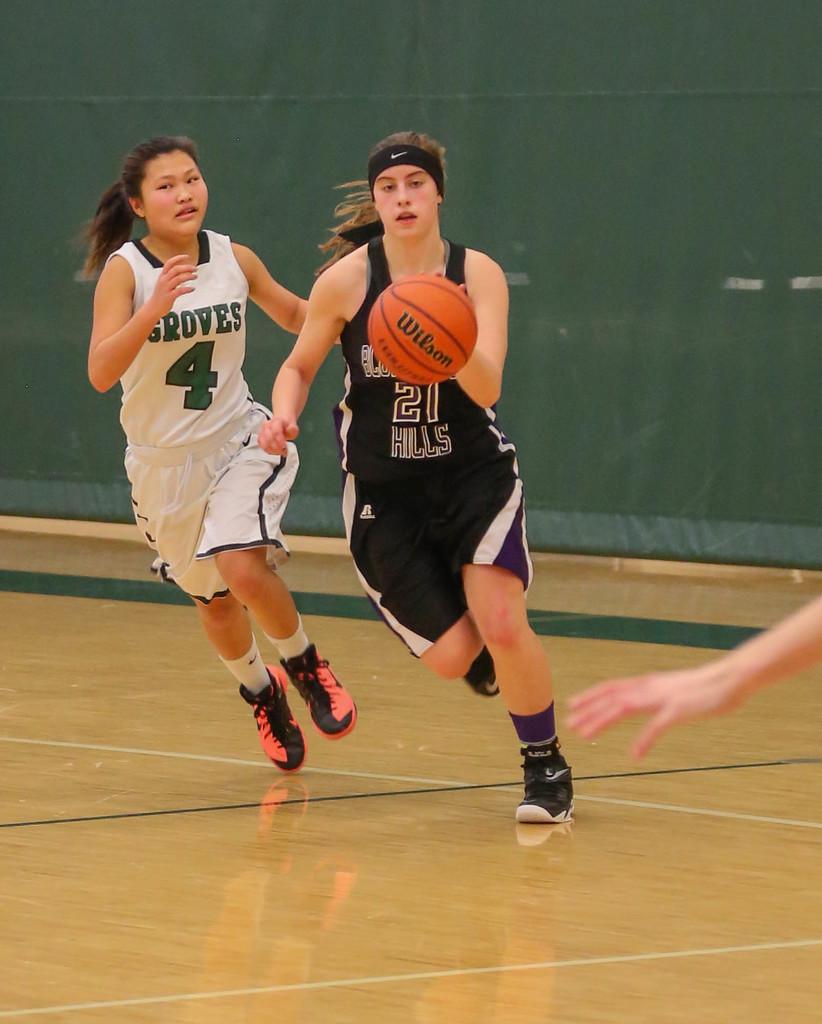What word is on the bottom of the black jersey?
Keep it short and to the point. Hills. What is the number on the white jersey?
Your answer should be compact. 4. 